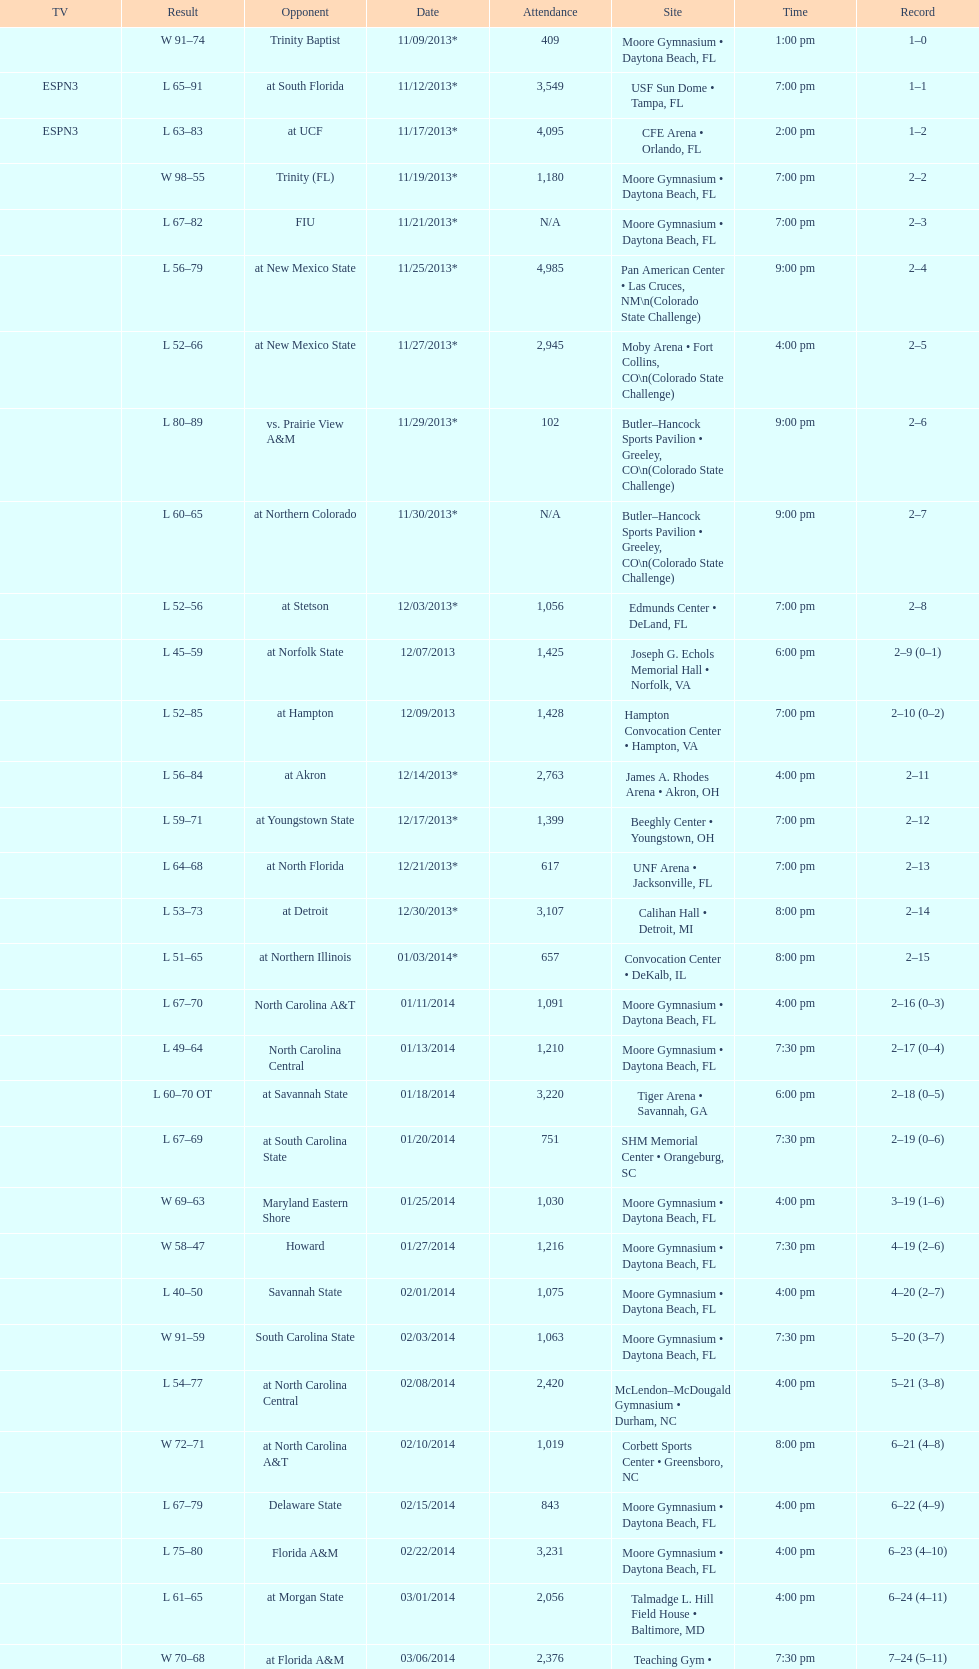How many games did the wildcats play in daytona beach, fl? 11. Would you be able to parse every entry in this table? {'header': ['TV', 'Result', 'Opponent', 'Date', 'Attendance', 'Site', 'Time', 'Record'], 'rows': [['', 'W\xa091–74', 'Trinity Baptist', '11/09/2013*', '409', 'Moore Gymnasium • Daytona Beach, FL', '1:00 pm', '1–0'], ['ESPN3', 'L\xa065–91', 'at\xa0South Florida', '11/12/2013*', '3,549', 'USF Sun Dome • Tampa, FL', '7:00 pm', '1–1'], ['ESPN3', 'L\xa063–83', 'at\xa0UCF', '11/17/2013*', '4,095', 'CFE Arena • Orlando, FL', '2:00 pm', '1–2'], ['', 'W\xa098–55', 'Trinity (FL)', '11/19/2013*', '1,180', 'Moore Gymnasium • Daytona Beach, FL', '7:00 pm', '2–2'], ['', 'L\xa067–82', 'FIU', '11/21/2013*', 'N/A', 'Moore Gymnasium • Daytona Beach, FL', '7:00 pm', '2–3'], ['', 'L\xa056–79', 'at\xa0New Mexico State', '11/25/2013*', '4,985', 'Pan American Center • Las Cruces, NM\\n(Colorado State Challenge)', '9:00 pm', '2–4'], ['', 'L\xa052–66', 'at\xa0New Mexico State', '11/27/2013*', '2,945', 'Moby Arena • Fort Collins, CO\\n(Colorado State Challenge)', '4:00 pm', '2–5'], ['', 'L\xa080–89', 'vs.\xa0Prairie View A&M', '11/29/2013*', '102', 'Butler–Hancock Sports Pavilion • Greeley, CO\\n(Colorado State Challenge)', '9:00 pm', '2–6'], ['', 'L\xa060–65', 'at\xa0Northern Colorado', '11/30/2013*', 'N/A', 'Butler–Hancock Sports Pavilion • Greeley, CO\\n(Colorado State Challenge)', '9:00 pm', '2–7'], ['', 'L\xa052–56', 'at\xa0Stetson', '12/03/2013*', '1,056', 'Edmunds Center • DeLand, FL', '7:00 pm', '2–8'], ['', 'L\xa045–59', 'at\xa0Norfolk State', '12/07/2013', '1,425', 'Joseph G. Echols Memorial Hall • Norfolk, VA', '6:00 pm', '2–9 (0–1)'], ['', 'L\xa052–85', 'at\xa0Hampton', '12/09/2013', '1,428', 'Hampton Convocation Center • Hampton, VA', '7:00 pm', '2–10 (0–2)'], ['', 'L\xa056–84', 'at\xa0Akron', '12/14/2013*', '2,763', 'James A. Rhodes Arena • Akron, OH', '4:00 pm', '2–11'], ['', 'L\xa059–71', 'at\xa0Youngstown State', '12/17/2013*', '1,399', 'Beeghly Center • Youngstown, OH', '7:00 pm', '2–12'], ['', 'L\xa064–68', 'at\xa0North Florida', '12/21/2013*', '617', 'UNF Arena • Jacksonville, FL', '7:00 pm', '2–13'], ['', 'L\xa053–73', 'at\xa0Detroit', '12/30/2013*', '3,107', 'Calihan Hall • Detroit, MI', '8:00 pm', '2–14'], ['', 'L\xa051–65', 'at\xa0Northern Illinois', '01/03/2014*', '657', 'Convocation Center • DeKalb, IL', '8:00 pm', '2–15'], ['', 'L\xa067–70', 'North Carolina A&T', '01/11/2014', '1,091', 'Moore Gymnasium • Daytona Beach, FL', '4:00 pm', '2–16 (0–3)'], ['', 'L\xa049–64', 'North Carolina Central', '01/13/2014', '1,210', 'Moore Gymnasium • Daytona Beach, FL', '7:30 pm', '2–17 (0–4)'], ['', 'L\xa060–70\xa0OT', 'at\xa0Savannah State', '01/18/2014', '3,220', 'Tiger Arena • Savannah, GA', '6:00 pm', '2–18 (0–5)'], ['', 'L\xa067–69', 'at\xa0South Carolina State', '01/20/2014', '751', 'SHM Memorial Center • Orangeburg, SC', '7:30 pm', '2–19 (0–6)'], ['', 'W\xa069–63', 'Maryland Eastern Shore', '01/25/2014', '1,030', 'Moore Gymnasium • Daytona Beach, FL', '4:00 pm', '3–19 (1–6)'], ['', 'W\xa058–47', 'Howard', '01/27/2014', '1,216', 'Moore Gymnasium • Daytona Beach, FL', '7:30 pm', '4–19 (2–6)'], ['', 'L\xa040–50', 'Savannah State', '02/01/2014', '1,075', 'Moore Gymnasium • Daytona Beach, FL', '4:00 pm', '4–20 (2–7)'], ['', 'W\xa091–59', 'South Carolina State', '02/03/2014', '1,063', 'Moore Gymnasium • Daytona Beach, FL', '7:30 pm', '5–20 (3–7)'], ['', 'L\xa054–77', 'at\xa0North Carolina Central', '02/08/2014', '2,420', 'McLendon–McDougald Gymnasium • Durham, NC', '4:00 pm', '5–21 (3–8)'], ['', 'W\xa072–71', 'at\xa0North Carolina A&T', '02/10/2014', '1,019', 'Corbett Sports Center • Greensboro, NC', '8:00 pm', '6–21 (4–8)'], ['', 'L\xa067–79', 'Delaware State', '02/15/2014', '843', 'Moore Gymnasium • Daytona Beach, FL', '4:00 pm', '6–22 (4–9)'], ['', 'L\xa075–80', 'Florida A&M', '02/22/2014', '3,231', 'Moore Gymnasium • Daytona Beach, FL', '4:00 pm', '6–23 (4–10)'], ['', 'L\xa061–65', 'at\xa0Morgan State', '03/01/2014', '2,056', 'Talmadge L. Hill Field House • Baltimore, MD', '4:00 pm', '6–24 (4–11)'], ['', 'W\xa070–68', 'at\xa0Florida A&M', '03/06/2014', '2,376', 'Teaching Gym • Tallahassee, FL', '7:30 pm', '7–24 (5–11)'], ['', 'L\xa068–75', 'vs.\xa0Coppin State', '03/11/2014', '4,658', 'Norfolk Scope • Norfolk, VA\\n(First round)', '6:30 pm', '7–25']]} 